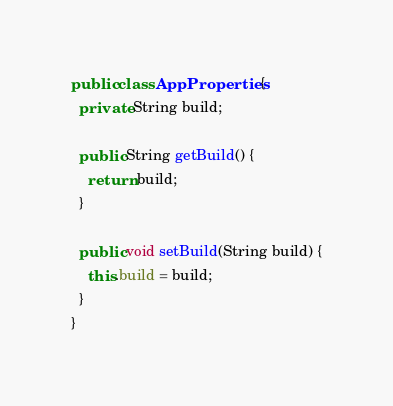Convert code to text. <code><loc_0><loc_0><loc_500><loc_500><_Java_>public class AppProperties {
  private String build;

  public String getBuild() {
    return build;
  }

  public void setBuild(String build) {
    this.build = build;
  }
}</code> 